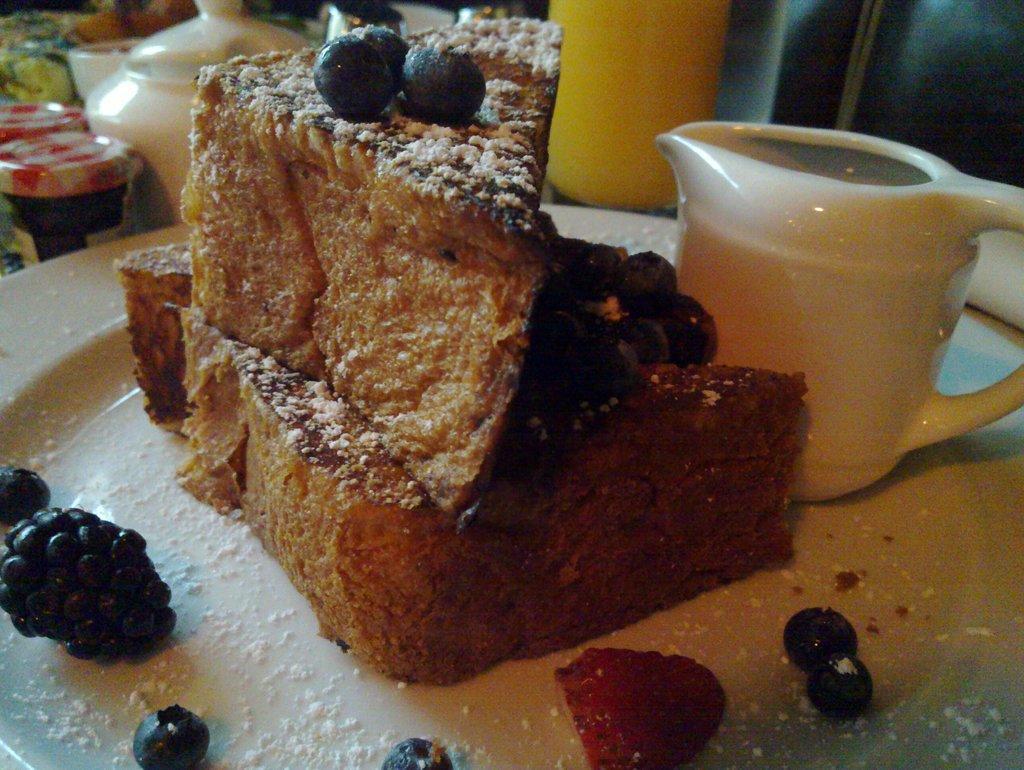Please provide a concise description of this image. In this picture, we can see a white plate and on the plate there is a cup and some food items. In front of the plate there are some objects. 